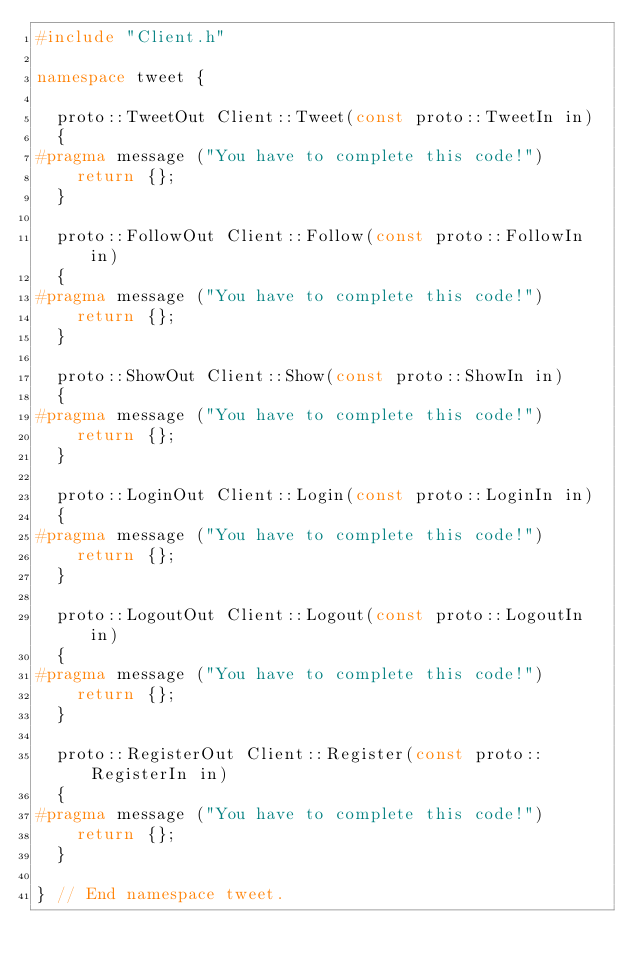<code> <loc_0><loc_0><loc_500><loc_500><_C++_>#include "Client.h"

namespace tweet {

	proto::TweetOut Client::Tweet(const proto::TweetIn in)
	{
#pragma message ("You have to complete this code!")
		return {};
	}

	proto::FollowOut Client::Follow(const proto::FollowIn in)
	{
#pragma message ("You have to complete this code!")
		return {};
	}

	proto::ShowOut Client::Show(const proto::ShowIn in)
	{
#pragma message ("You have to complete this code!")
		return {};
	}

	proto::LoginOut Client::Login(const proto::LoginIn in)
	{
#pragma message ("You have to complete this code!")
		return {};
	}

	proto::LogoutOut Client::Logout(const proto::LogoutIn in)
	{
#pragma message ("You have to complete this code!")
		return {};
	}

	proto::RegisterOut Client::Register(const proto::RegisterIn in)
	{
#pragma message ("You have to complete this code!")
		return {};
	}

} // End namespace tweet.
</code> 